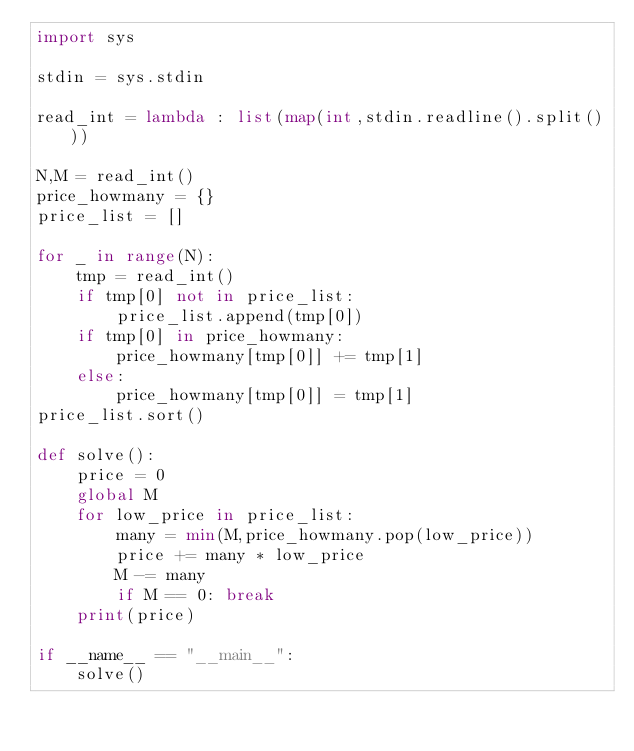<code> <loc_0><loc_0><loc_500><loc_500><_Python_>import sys

stdin = sys.stdin

read_int = lambda : list(map(int,stdin.readline().split()))

N,M = read_int()
price_howmany = {}
price_list = []

for _ in range(N):
    tmp = read_int()
    if tmp[0] not in price_list:
        price_list.append(tmp[0])
    if tmp[0] in price_howmany:
        price_howmany[tmp[0]] += tmp[1]
    else:
        price_howmany[tmp[0]] = tmp[1]
price_list.sort()

def solve():
    price = 0
    global M
    for low_price in price_list:
        many = min(M,price_howmany.pop(low_price))
        price += many * low_price
        M -= many
        if M == 0: break
    print(price)

if __name__ == "__main__":
    solve()</code> 